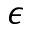<formula> <loc_0><loc_0><loc_500><loc_500>\epsilon</formula> 